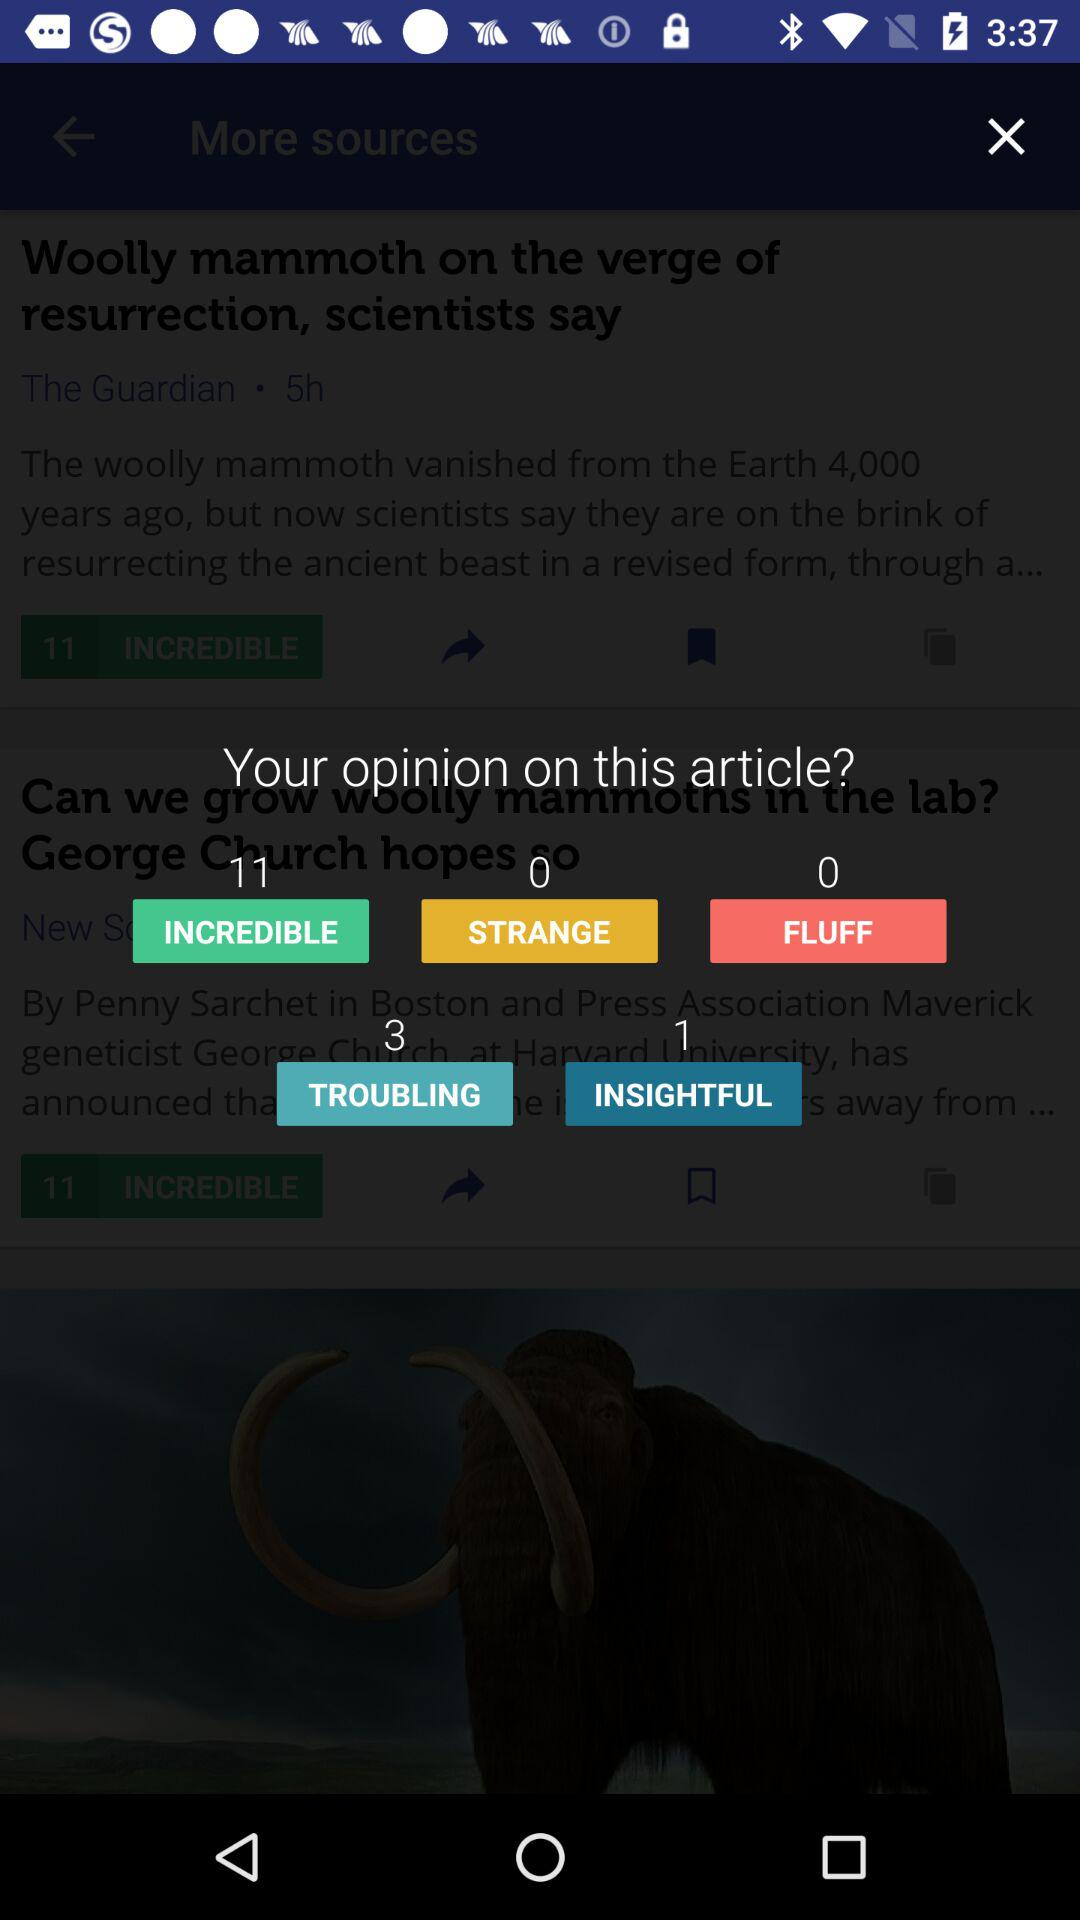What's the number of viewers who selected "INCREDIBLE" for the article? The number of viewers is 11. 